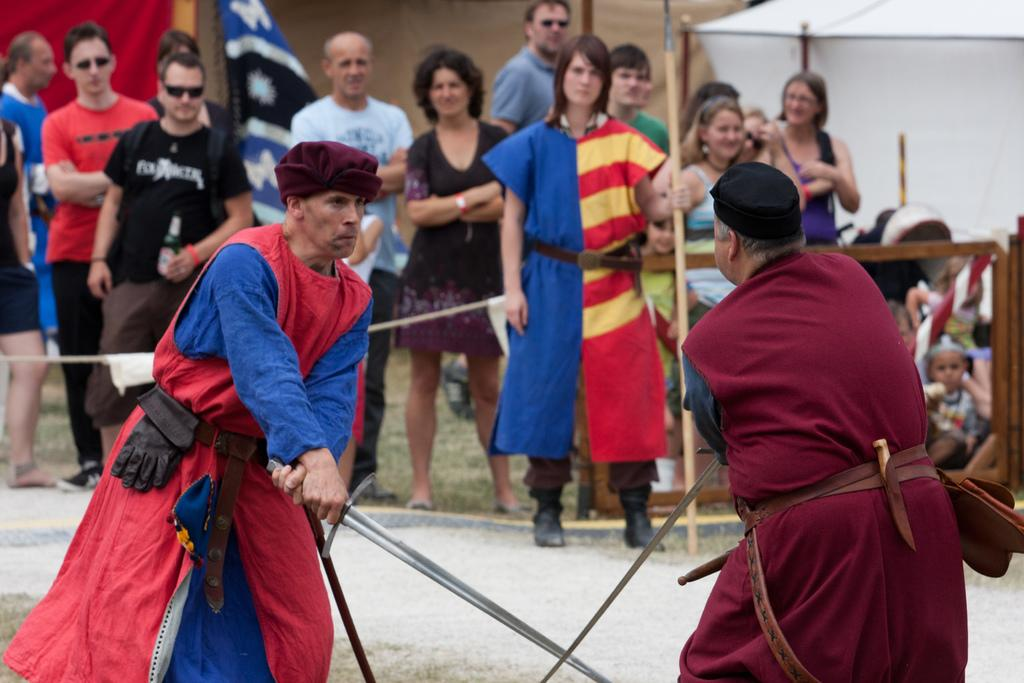What are the two persons in the image doing? The two persons in the image are fighting with swords. Are there any other people present in the image? Yes, there are people standing around, watching the fight. What can be seen in the background or alongside the fight? There are flags visible in the image. What is the texture of the eggs in the image? There are no eggs present in the image. How do the fighters answer questions during the fight? The fighters are not answering questions during the fight; they are engaged in a sword fight. 